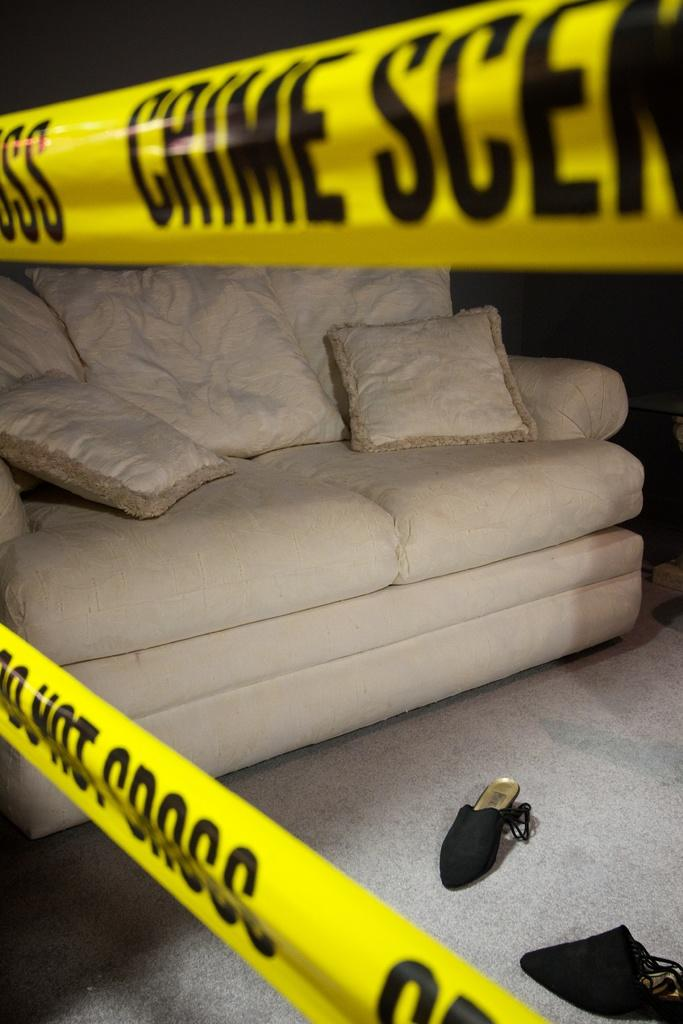What type of furniture is in the image? There is a white color sofa in the image. How many pillows are on the sofa? There are three pillows on the sofa. What color is the plaster in the image? There is yellow color plaster in the image. How many chapels are in the image? There are two chapels in the image. What type of soup is being served in the image? There is no soup present in the image. Is there any mention of a knee in the image? There is no mention of a knee in the image. 